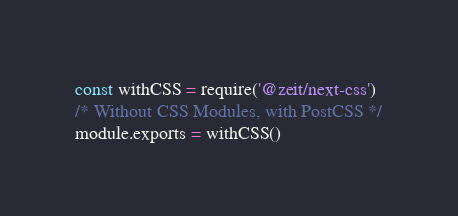<code> <loc_0><loc_0><loc_500><loc_500><_JavaScript_>const withCSS = require('@zeit/next-css')
/* Without CSS Modules, with PostCSS */
module.exports = withCSS()
</code> 